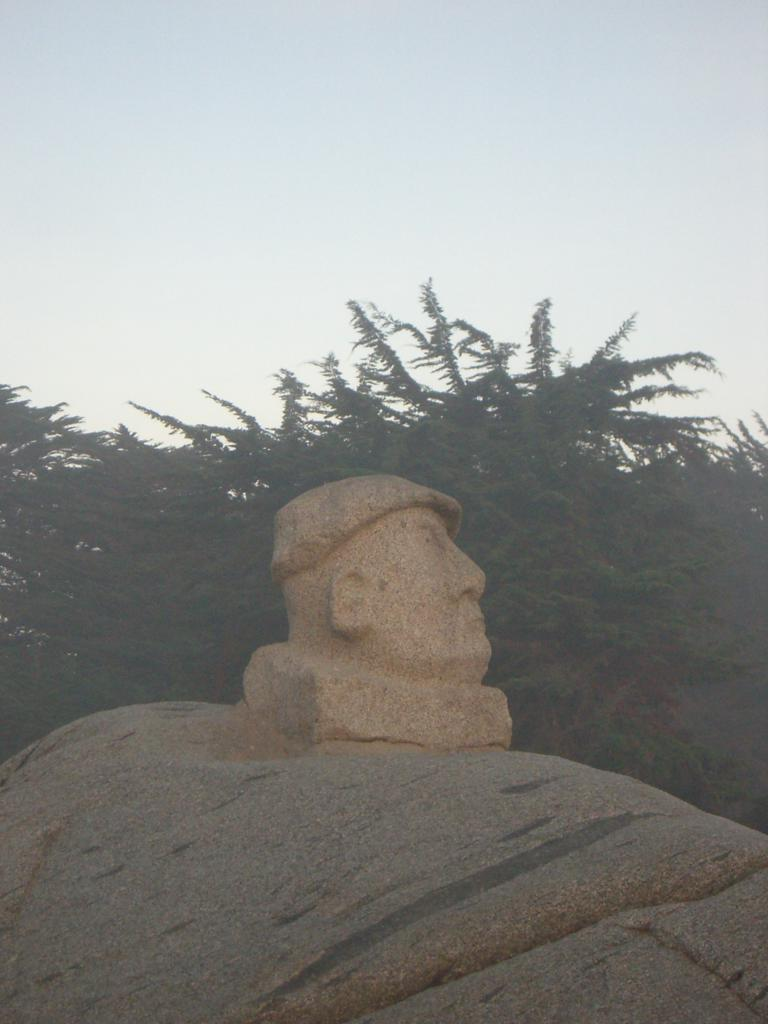What is the main subject of the image? The main subject of the image is a sculpture made up of a rock. Can you describe the sculpture in more detail? The sculpture is made up of a rock, but no further details are provided. What can be seen in the background of the image? There are trees in the background of the image. How many crows are perched on the rock sculpture in the image? There are no crows present in the image; it only features a rock sculpture and trees in the background. 